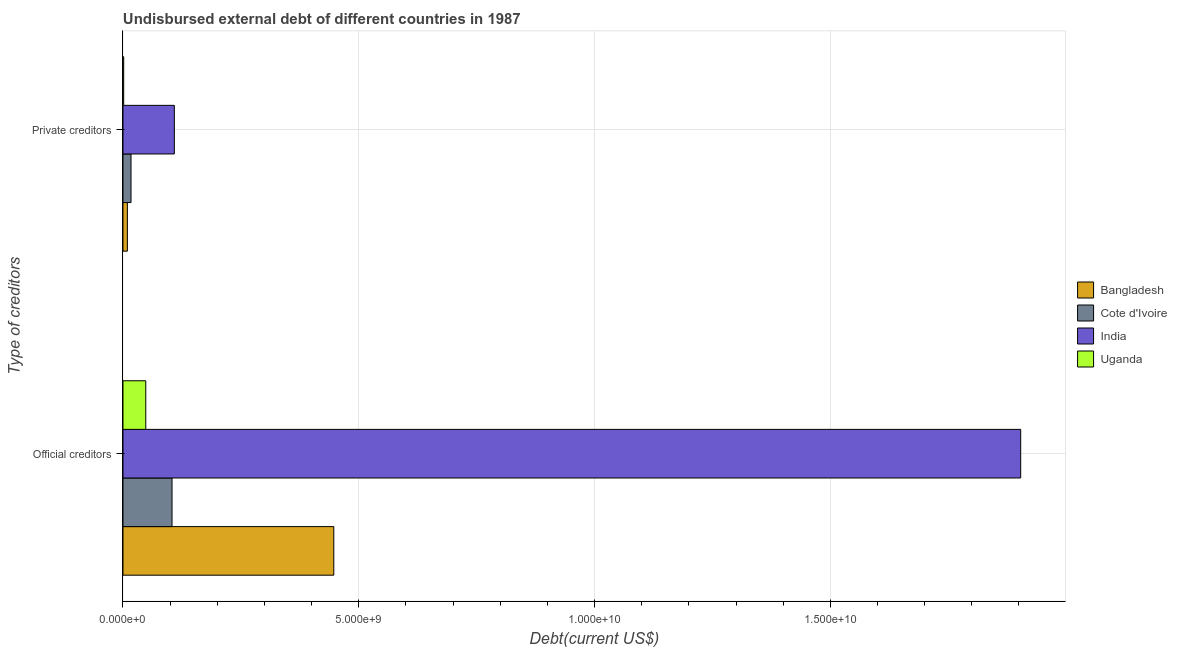How many different coloured bars are there?
Offer a terse response. 4. How many groups of bars are there?
Your response must be concise. 2. Are the number of bars per tick equal to the number of legend labels?
Provide a short and direct response. Yes. How many bars are there on the 1st tick from the top?
Offer a terse response. 4. What is the label of the 2nd group of bars from the top?
Offer a terse response. Official creditors. What is the undisbursed external debt of private creditors in Uganda?
Keep it short and to the point. 1.51e+07. Across all countries, what is the maximum undisbursed external debt of private creditors?
Provide a short and direct response. 1.09e+09. Across all countries, what is the minimum undisbursed external debt of private creditors?
Give a very brief answer. 1.51e+07. In which country was the undisbursed external debt of official creditors minimum?
Provide a succinct answer. Uganda. What is the total undisbursed external debt of private creditors in the graph?
Your answer should be compact. 1.37e+09. What is the difference between the undisbursed external debt of private creditors in Cote d'Ivoire and that in Uganda?
Your answer should be compact. 1.55e+08. What is the difference between the undisbursed external debt of private creditors in Uganda and the undisbursed external debt of official creditors in Bangladesh?
Offer a terse response. -4.46e+09. What is the average undisbursed external debt of official creditors per country?
Your answer should be very brief. 6.26e+09. What is the difference between the undisbursed external debt of private creditors and undisbursed external debt of official creditors in India?
Offer a terse response. -1.79e+1. What is the ratio of the undisbursed external debt of official creditors in Cote d'Ivoire to that in India?
Provide a short and direct response. 0.05. Is the undisbursed external debt of official creditors in Cote d'Ivoire less than that in India?
Provide a short and direct response. Yes. In how many countries, is the undisbursed external debt of private creditors greater than the average undisbursed external debt of private creditors taken over all countries?
Provide a short and direct response. 1. What does the 3rd bar from the top in Official creditors represents?
Your answer should be compact. Cote d'Ivoire. What does the 1st bar from the bottom in Official creditors represents?
Offer a terse response. Bangladesh. How many countries are there in the graph?
Provide a short and direct response. 4. Does the graph contain any zero values?
Your response must be concise. No. Does the graph contain grids?
Provide a short and direct response. Yes. What is the title of the graph?
Provide a short and direct response. Undisbursed external debt of different countries in 1987. Does "United Arab Emirates" appear as one of the legend labels in the graph?
Your response must be concise. No. What is the label or title of the X-axis?
Make the answer very short. Debt(current US$). What is the label or title of the Y-axis?
Your response must be concise. Type of creditors. What is the Debt(current US$) in Bangladesh in Official creditors?
Your response must be concise. 4.47e+09. What is the Debt(current US$) in Cote d'Ivoire in Official creditors?
Give a very brief answer. 1.04e+09. What is the Debt(current US$) in India in Official creditors?
Your answer should be compact. 1.90e+1. What is the Debt(current US$) in Uganda in Official creditors?
Make the answer very short. 4.83e+08. What is the Debt(current US$) in Bangladesh in Private creditors?
Offer a terse response. 9.33e+07. What is the Debt(current US$) of Cote d'Ivoire in Private creditors?
Give a very brief answer. 1.70e+08. What is the Debt(current US$) of India in Private creditors?
Provide a succinct answer. 1.09e+09. What is the Debt(current US$) of Uganda in Private creditors?
Your response must be concise. 1.51e+07. Across all Type of creditors, what is the maximum Debt(current US$) in Bangladesh?
Make the answer very short. 4.47e+09. Across all Type of creditors, what is the maximum Debt(current US$) in Cote d'Ivoire?
Keep it short and to the point. 1.04e+09. Across all Type of creditors, what is the maximum Debt(current US$) in India?
Your response must be concise. 1.90e+1. Across all Type of creditors, what is the maximum Debt(current US$) in Uganda?
Your response must be concise. 4.83e+08. Across all Type of creditors, what is the minimum Debt(current US$) of Bangladesh?
Offer a terse response. 9.33e+07. Across all Type of creditors, what is the minimum Debt(current US$) in Cote d'Ivoire?
Offer a terse response. 1.70e+08. Across all Type of creditors, what is the minimum Debt(current US$) of India?
Ensure brevity in your answer.  1.09e+09. Across all Type of creditors, what is the minimum Debt(current US$) in Uganda?
Ensure brevity in your answer.  1.51e+07. What is the total Debt(current US$) in Bangladesh in the graph?
Offer a terse response. 4.56e+09. What is the total Debt(current US$) of Cote d'Ivoire in the graph?
Keep it short and to the point. 1.21e+09. What is the total Debt(current US$) of India in the graph?
Give a very brief answer. 2.01e+1. What is the total Debt(current US$) in Uganda in the graph?
Provide a succinct answer. 4.99e+08. What is the difference between the Debt(current US$) of Bangladesh in Official creditors and that in Private creditors?
Make the answer very short. 4.38e+09. What is the difference between the Debt(current US$) in Cote d'Ivoire in Official creditors and that in Private creditors?
Make the answer very short. 8.70e+08. What is the difference between the Debt(current US$) in India in Official creditors and that in Private creditors?
Your response must be concise. 1.79e+1. What is the difference between the Debt(current US$) of Uganda in Official creditors and that in Private creditors?
Your response must be concise. 4.68e+08. What is the difference between the Debt(current US$) in Bangladesh in Official creditors and the Debt(current US$) in Cote d'Ivoire in Private creditors?
Provide a short and direct response. 4.30e+09. What is the difference between the Debt(current US$) in Bangladesh in Official creditors and the Debt(current US$) in India in Private creditors?
Your answer should be very brief. 3.38e+09. What is the difference between the Debt(current US$) in Bangladesh in Official creditors and the Debt(current US$) in Uganda in Private creditors?
Give a very brief answer. 4.46e+09. What is the difference between the Debt(current US$) in Cote d'Ivoire in Official creditors and the Debt(current US$) in India in Private creditors?
Ensure brevity in your answer.  -4.90e+07. What is the difference between the Debt(current US$) of Cote d'Ivoire in Official creditors and the Debt(current US$) of Uganda in Private creditors?
Give a very brief answer. 1.03e+09. What is the difference between the Debt(current US$) in India in Official creditors and the Debt(current US$) in Uganda in Private creditors?
Keep it short and to the point. 1.90e+1. What is the average Debt(current US$) of Bangladesh per Type of creditors?
Offer a terse response. 2.28e+09. What is the average Debt(current US$) of Cote d'Ivoire per Type of creditors?
Give a very brief answer. 6.05e+08. What is the average Debt(current US$) of India per Type of creditors?
Provide a short and direct response. 1.01e+1. What is the average Debt(current US$) of Uganda per Type of creditors?
Make the answer very short. 2.49e+08. What is the difference between the Debt(current US$) in Bangladesh and Debt(current US$) in Cote d'Ivoire in Official creditors?
Your answer should be very brief. 3.43e+09. What is the difference between the Debt(current US$) in Bangladesh and Debt(current US$) in India in Official creditors?
Your answer should be compact. -1.46e+1. What is the difference between the Debt(current US$) in Bangladesh and Debt(current US$) in Uganda in Official creditors?
Your response must be concise. 3.99e+09. What is the difference between the Debt(current US$) in Cote d'Ivoire and Debt(current US$) in India in Official creditors?
Your answer should be very brief. -1.80e+1. What is the difference between the Debt(current US$) of Cote d'Ivoire and Debt(current US$) of Uganda in Official creditors?
Offer a very short reply. 5.57e+08. What is the difference between the Debt(current US$) of India and Debt(current US$) of Uganda in Official creditors?
Ensure brevity in your answer.  1.86e+1. What is the difference between the Debt(current US$) of Bangladesh and Debt(current US$) of Cote d'Ivoire in Private creditors?
Make the answer very short. -7.69e+07. What is the difference between the Debt(current US$) in Bangladesh and Debt(current US$) in India in Private creditors?
Offer a very short reply. -9.96e+08. What is the difference between the Debt(current US$) in Bangladesh and Debt(current US$) in Uganda in Private creditors?
Keep it short and to the point. 7.83e+07. What is the difference between the Debt(current US$) of Cote d'Ivoire and Debt(current US$) of India in Private creditors?
Your response must be concise. -9.19e+08. What is the difference between the Debt(current US$) in Cote d'Ivoire and Debt(current US$) in Uganda in Private creditors?
Your response must be concise. 1.55e+08. What is the difference between the Debt(current US$) of India and Debt(current US$) of Uganda in Private creditors?
Your answer should be very brief. 1.07e+09. What is the ratio of the Debt(current US$) in Bangladesh in Official creditors to that in Private creditors?
Offer a terse response. 47.91. What is the ratio of the Debt(current US$) in Cote d'Ivoire in Official creditors to that in Private creditors?
Offer a very short reply. 6.11. What is the ratio of the Debt(current US$) of India in Official creditors to that in Private creditors?
Give a very brief answer. 17.48. What is the ratio of the Debt(current US$) of Uganda in Official creditors to that in Private creditors?
Your answer should be very brief. 32.1. What is the difference between the highest and the second highest Debt(current US$) of Bangladesh?
Offer a very short reply. 4.38e+09. What is the difference between the highest and the second highest Debt(current US$) of Cote d'Ivoire?
Your answer should be compact. 8.70e+08. What is the difference between the highest and the second highest Debt(current US$) in India?
Provide a short and direct response. 1.79e+1. What is the difference between the highest and the second highest Debt(current US$) of Uganda?
Give a very brief answer. 4.68e+08. What is the difference between the highest and the lowest Debt(current US$) of Bangladesh?
Offer a terse response. 4.38e+09. What is the difference between the highest and the lowest Debt(current US$) of Cote d'Ivoire?
Your answer should be very brief. 8.70e+08. What is the difference between the highest and the lowest Debt(current US$) of India?
Your response must be concise. 1.79e+1. What is the difference between the highest and the lowest Debt(current US$) of Uganda?
Provide a short and direct response. 4.68e+08. 